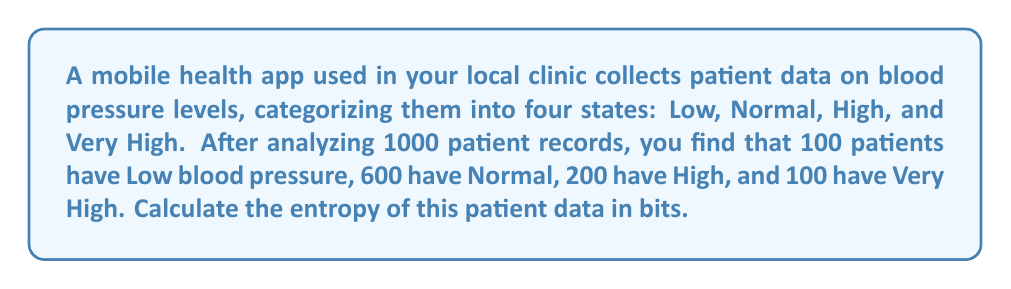Can you answer this question? To calculate the entropy of the patient data, we'll use Shannon's entropy formula:

$$H = -\sum_{i=1}^{n} p_i \log_2(p_i)$$

Where:
- $H$ is the entropy in bits
- $p_i$ is the probability of each state
- $n$ is the number of possible states (in this case, 4)

Step 1: Calculate the probabilities for each state:
- $p_{Low} = 100/1000 = 0.1$
- $p_{Normal} = 600/1000 = 0.6$
- $p_{High} = 200/1000 = 0.2$
- $p_{Very High} = 100/1000 = 0.1$

Step 2: Apply the entropy formula:

$$\begin{align}
H &= -[p_{Low} \log_2(p_{Low}) + p_{Normal} \log_2(p_{Normal}) + p_{High} \log_2(p_{High}) + p_{Very High} \log_2(p_{Very High})] \\
&= -[0.1 \log_2(0.1) + 0.6 \log_2(0.6) + 0.2 \log_2(0.2) + 0.1 \log_2(0.1)] \\
&= -[0.1 \cdot (-3.32) + 0.6 \cdot (-0.74) + 0.2 \cdot (-2.32) + 0.1 \cdot (-3.32)] \\
&= -[-0.332 - 0.444 - 0.464 - 0.332] \\
&= 1.572 \text{ bits}
\end{align}$$
Answer: The entropy of the patient data is approximately 1.572 bits. 